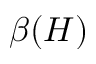Convert formula to latex. <formula><loc_0><loc_0><loc_500><loc_500>\beta ( H )</formula> 